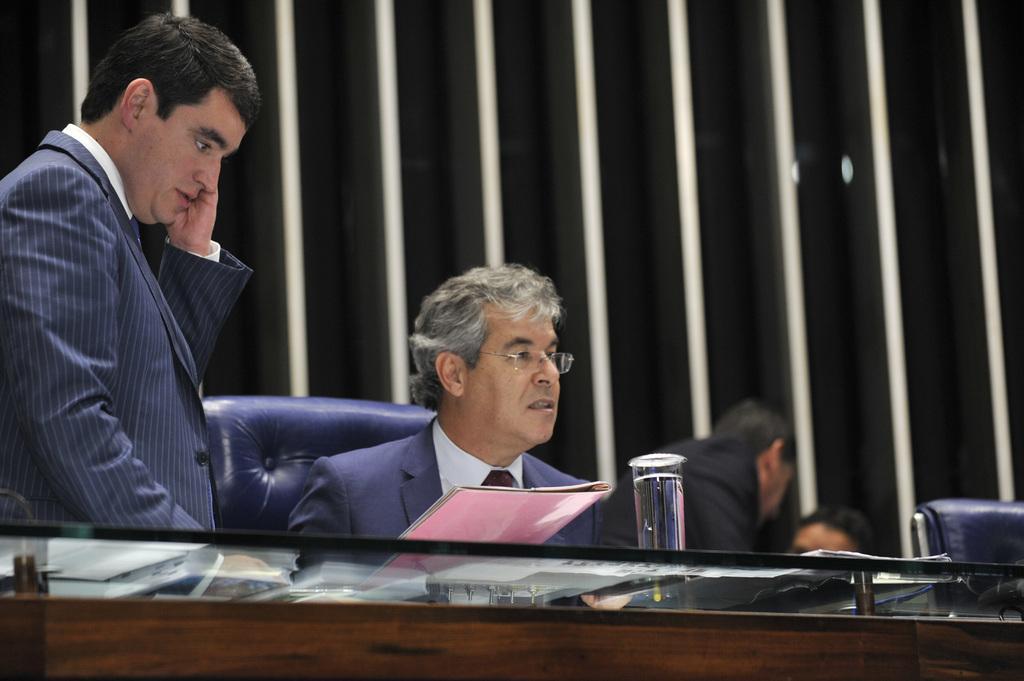In one or two sentences, can you explain what this image depicts? In this picture there is a man who is wearing spectacle, suit and holding a files. He is sitting on the blue color chair. On the table we can see water grass and book. On the left there is a man who is standing near to the table. On the right background there are two persons were talking with each other. On the background we can see pipes. 